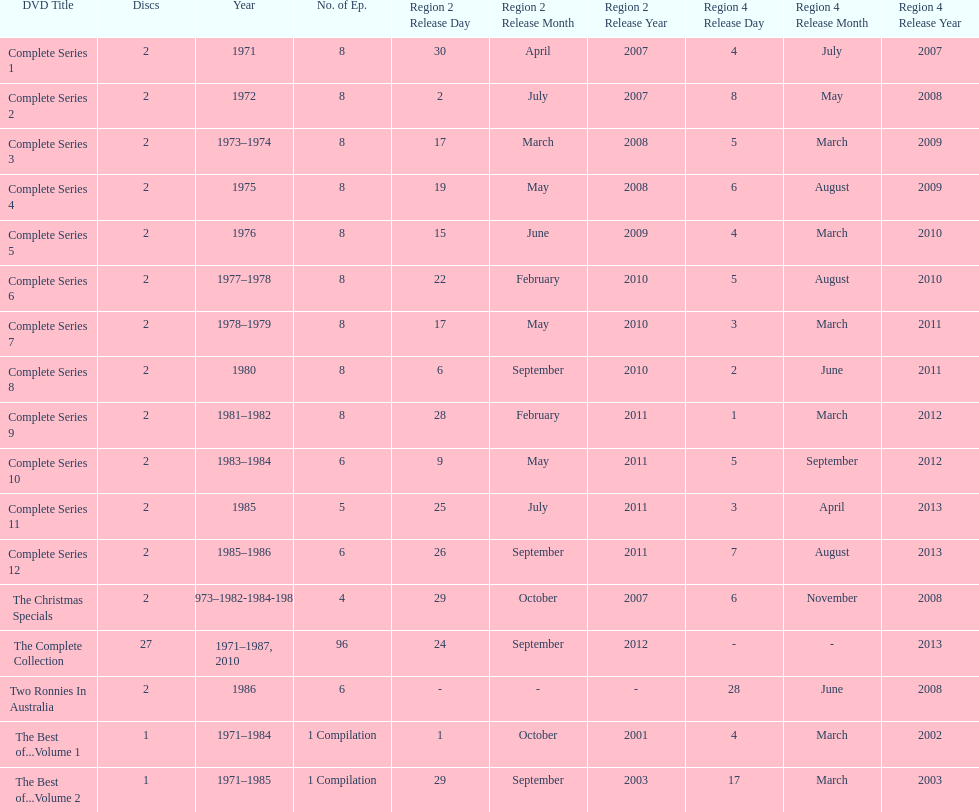The complete collection has 96 episodes, but the christmas specials only has how many episodes? 4. 